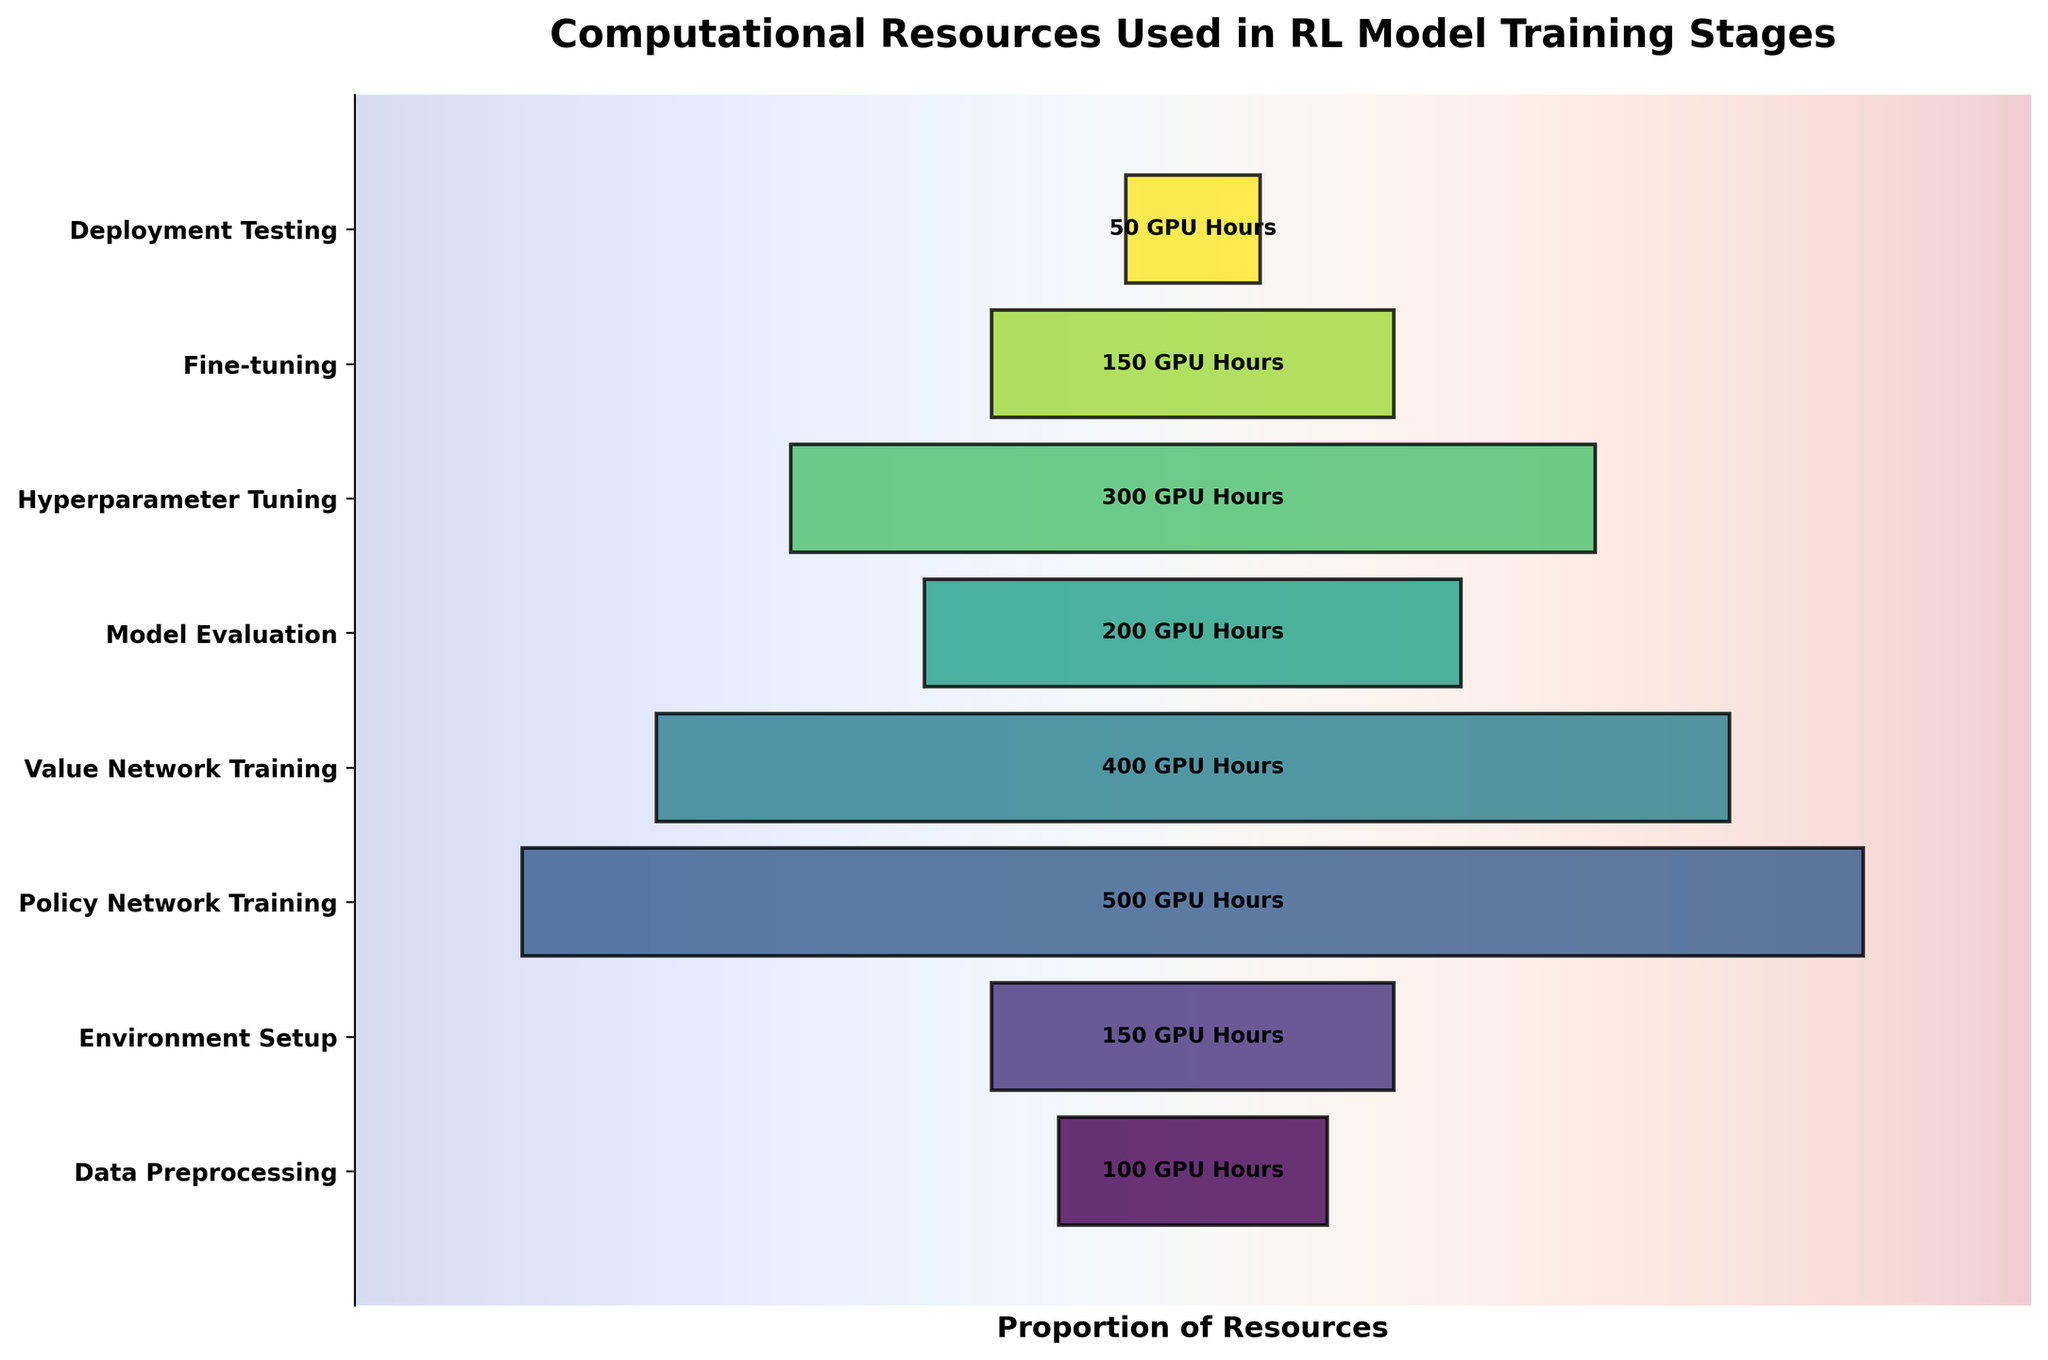What's the title of the chart? The title of the chart is found at the top of the figure. It provides a summary of what the figure is about. Based on the description provided, the title is "Computational Resources Used in RL Model Training Stages".
Answer: Computational Resources Used in RL Model Training Stages What stage consumes the highest computational resources? To find the stage with the highest resource consumption, we look for the widest segment in the funnel chart. The widest segment represents the highest value. The Policy Network Training stage is the largest, indicating the highest resource consumption.
Answer: Policy Network Training Which stage uses the least amount of computational resources? In a funnel chart, the stage with the smallest width represents the least resources used. The narrowest segment found at the bottom of the funnel chart corresponds to Deployment Testing.
Answer: Deployment Testing How many stages are represented in the chart? To determine the number of stages, count all the distinct segments in the funnel chart. We have the following stages: Data Preprocessing, Environment Setup, Policy Network Training, Value Network Training, Model Evaluation, Hyperparameter Tuning, Fine-tuning, Deployment Testing.
Answer: 8 What is the total computational resource used in the model training? To determine the total computational resources, sum up all the GPU hours used across all the stages: 100 + 150 + 500 + 400 + 200 + 300 + 150 + 50.
Answer: 1850 Which stages use exactly 150 GPU hours? Look for the segments with the label "150 GPU Hours". According to the chart, these stages are Environment Setup and Fine-tuning.
Answer: Environment Setup and Fine-tuning Compare the computational resources used in Value Network Training and Model Evaluation. Which one is higher and by how much? Check the widths of the segments labeled "Value Network Training" and "Model Evaluation". Value Network Training is 400 GPU hours and Model Evaluation is 200 GPU hours. The difference is 400 - 200.
Answer: Value Network Training by 200 GPU hours What is the average computational resource used across all stages? To find the average, divide the total GPU hours by the number of stages. That is, 1850 GPU hours / 8 stages.
Answer: 231.25 What proportion of total computational resources is used in the Policy Network Training stage? First, identify the GPU hours for Policy Network Training, which is 500. Then, divide it by the total GPU hours and multiply by 100 to get the percentage: (500 / 1850) * 100.
Answer: 27.03% Describe the trend in the computational resource allocation from Data Preprocessing to Deployment Testing. Observing the funnel chart, there is an initial increase peaking at Policy Network Training followed by a gradual decrease through Value Network Training, Model Evaluation, Hyperparameter Tuning, Fine-Tuning, and finally reaching the lowest at Deployment Testing.
Answer: Initial increase, peak, then gradual decrease 